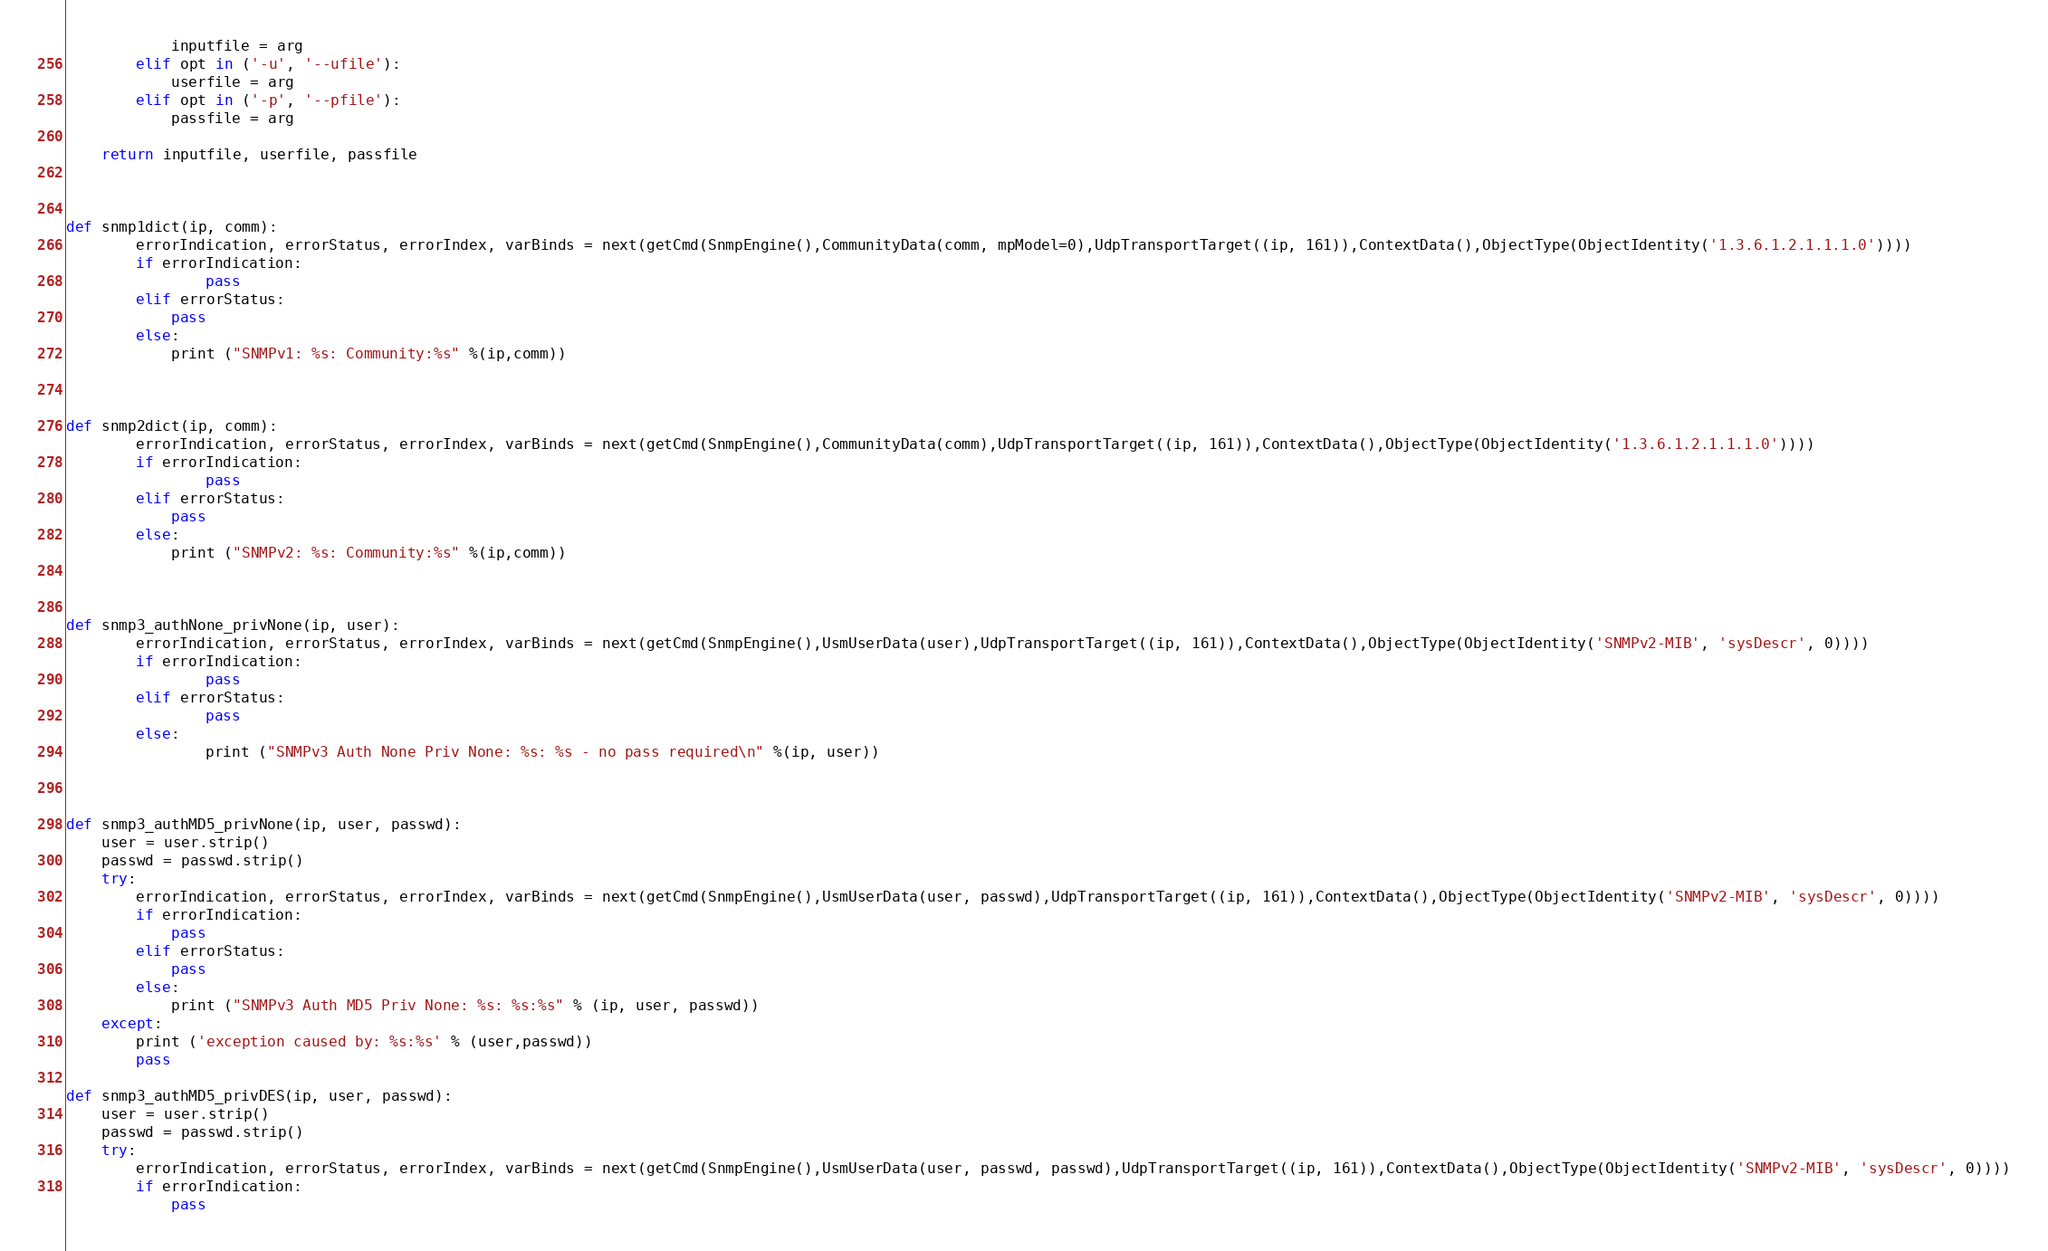Convert code to text. <code><loc_0><loc_0><loc_500><loc_500><_Python_>            inputfile = arg
        elif opt in ('-u', '--ufile'):
            userfile = arg
        elif opt in ('-p', '--pfile'):
            passfile = arg

    return inputfile, userfile, passfile



def snmp1dict(ip, comm):
        errorIndication, errorStatus, errorIndex, varBinds = next(getCmd(SnmpEngine(),CommunityData(comm, mpModel=0),UdpTransportTarget((ip, 161)),ContextData(),ObjectType(ObjectIdentity('1.3.6.1.2.1.1.1.0'))))
        if errorIndication:
                pass
        elif errorStatus:
            pass
        else:
            print ("SNMPv1: %s: Community:%s" %(ip,comm))



def snmp2dict(ip, comm):
        errorIndication, errorStatus, errorIndex, varBinds = next(getCmd(SnmpEngine(),CommunityData(comm),UdpTransportTarget((ip, 161)),ContextData(),ObjectType(ObjectIdentity('1.3.6.1.2.1.1.1.0'))))
        if errorIndication:
                pass
        elif errorStatus:
            pass
        else:
            print ("SNMPv2: %s: Community:%s" %(ip,comm))
         


def snmp3_authNone_privNone(ip, user):
        errorIndication, errorStatus, errorIndex, varBinds = next(getCmd(SnmpEngine(),UsmUserData(user),UdpTransportTarget((ip, 161)),ContextData(),ObjectType(ObjectIdentity('SNMPv2-MIB', 'sysDescr', 0))))
        if errorIndication:
                pass
        elif errorStatus:
                pass
        else:
                print ("SNMPv3 Auth None Priv None: %s: %s - no pass required\n" %(ip, user))



def snmp3_authMD5_privNone(ip, user, passwd):
    user = user.strip()
    passwd = passwd.strip()
    try:
        errorIndication, errorStatus, errorIndex, varBinds = next(getCmd(SnmpEngine(),UsmUserData(user, passwd),UdpTransportTarget((ip, 161)),ContextData(),ObjectType(ObjectIdentity('SNMPv2-MIB', 'sysDescr', 0))))
        if errorIndication:
            pass
        elif errorStatus:
            pass
        else:
            print ("SNMPv3 Auth MD5 Priv None: %s: %s:%s" % (ip, user, passwd))
    except:
        print ('exception caused by: %s:%s' % (user,passwd))
        pass

def snmp3_authMD5_privDES(ip, user, passwd):
    user = user.strip()
    passwd = passwd.strip()
    try:
        errorIndication, errorStatus, errorIndex, varBinds = next(getCmd(SnmpEngine(),UsmUserData(user, passwd, passwd),UdpTransportTarget((ip, 161)),ContextData(),ObjectType(ObjectIdentity('SNMPv2-MIB', 'sysDescr', 0))))
        if errorIndication:
            pass</code> 